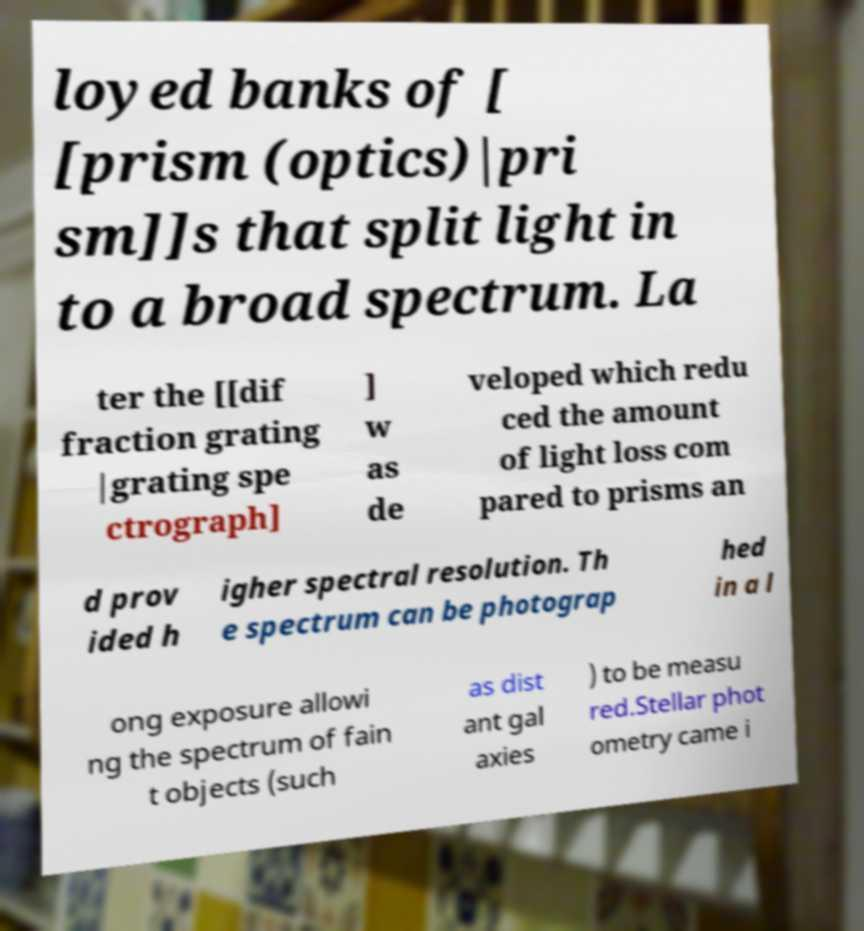Can you accurately transcribe the text from the provided image for me? loyed banks of [ [prism (optics)|pri sm]]s that split light in to a broad spectrum. La ter the [[dif fraction grating |grating spe ctrograph] ] w as de veloped which redu ced the amount of light loss com pared to prisms an d prov ided h igher spectral resolution. Th e spectrum can be photograp hed in a l ong exposure allowi ng the spectrum of fain t objects (such as dist ant gal axies ) to be measu red.Stellar phot ometry came i 